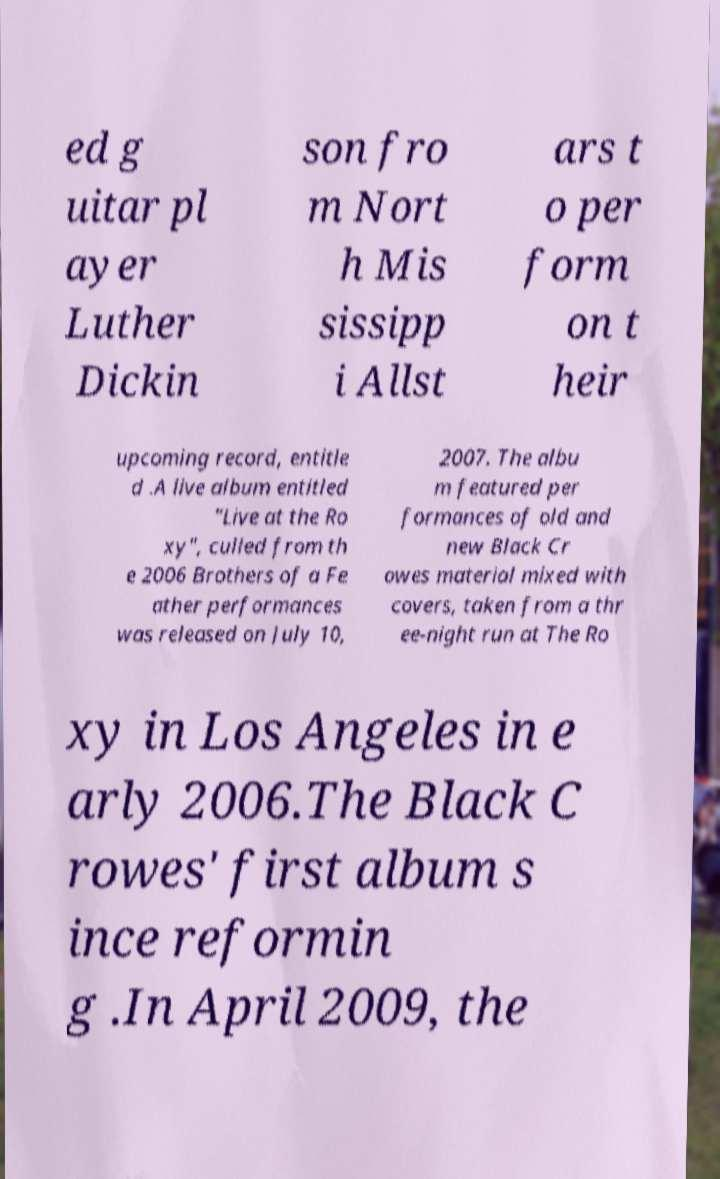Could you assist in decoding the text presented in this image and type it out clearly? ed g uitar pl ayer Luther Dickin son fro m Nort h Mis sissipp i Allst ars t o per form on t heir upcoming record, entitle d .A live album entitled "Live at the Ro xy", culled from th e 2006 Brothers of a Fe ather performances was released on July 10, 2007. The albu m featured per formances of old and new Black Cr owes material mixed with covers, taken from a thr ee-night run at The Ro xy in Los Angeles in e arly 2006.The Black C rowes' first album s ince reformin g .In April 2009, the 